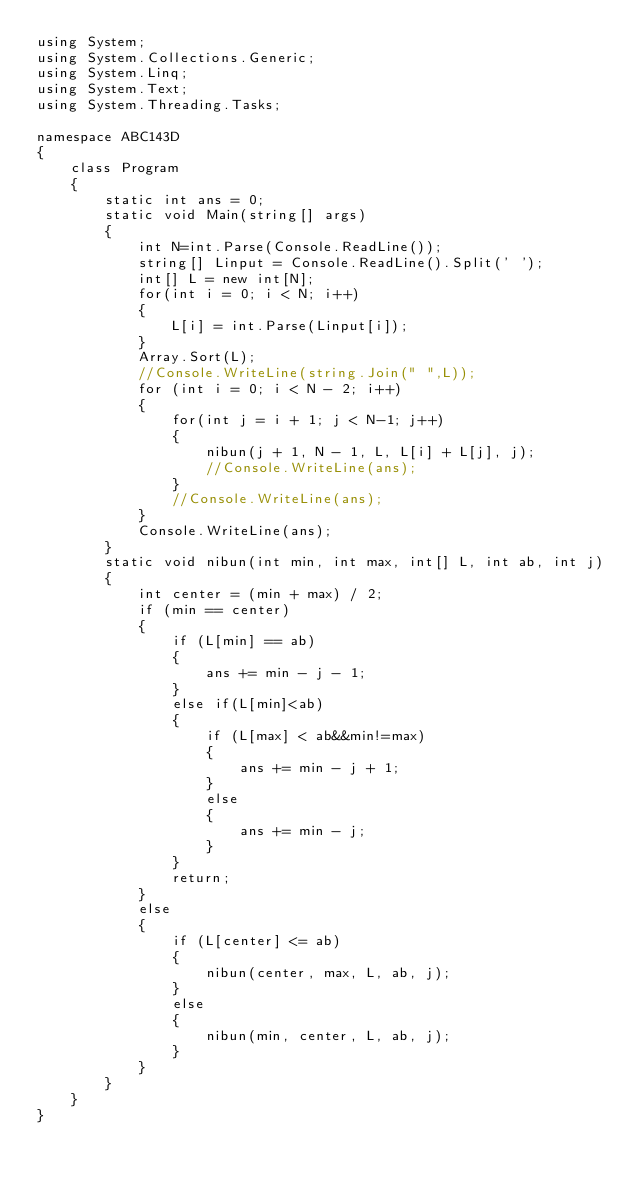<code> <loc_0><loc_0><loc_500><loc_500><_C#_>using System;
using System.Collections.Generic;
using System.Linq;
using System.Text;
using System.Threading.Tasks;

namespace ABC143D
{
    class Program
    {
        static int ans = 0;
        static void Main(string[] args)
        {
            int N=int.Parse(Console.ReadLine());
            string[] Linput = Console.ReadLine().Split(' ');
            int[] L = new int[N];
            for(int i = 0; i < N; i++)
            {
                L[i] = int.Parse(Linput[i]);
            }
            Array.Sort(L);
            //Console.WriteLine(string.Join(" ",L));
            for (int i = 0; i < N - 2; i++)
            {
                for(int j = i + 1; j < N-1; j++)
                {
                    nibun(j + 1, N - 1, L, L[i] + L[j], j);
                    //Console.WriteLine(ans);
                }
                //Console.WriteLine(ans);
            }
            Console.WriteLine(ans);
        }
        static void nibun(int min, int max, int[] L, int ab, int j)
        {
            int center = (min + max) / 2;
            if (min == center)
            {
                if (L[min] == ab)
                {
                    ans += min - j - 1;
                }
                else if(L[min]<ab)
                {
                    if (L[max] < ab&&min!=max)
                    {
                        ans += min - j + 1;
                    }
                    else
                    {
                        ans += min - j;
                    }
                }
                return;
            }
            else
            {
                if (L[center] <= ab)
                {
                    nibun(center, max, L, ab, j);
                }
                else
                {
                    nibun(min, center, L, ab, j);
                }
            }
        }
    }
}
</code> 